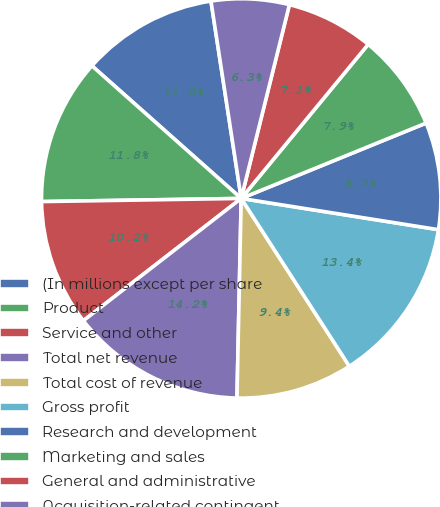Convert chart. <chart><loc_0><loc_0><loc_500><loc_500><pie_chart><fcel>(In millions except per share<fcel>Product<fcel>Service and other<fcel>Total net revenue<fcel>Total cost of revenue<fcel>Gross profit<fcel>Research and development<fcel>Marketing and sales<fcel>General and administrative<fcel>Acquisition-related contingent<nl><fcel>11.02%<fcel>11.81%<fcel>10.24%<fcel>14.17%<fcel>9.45%<fcel>13.39%<fcel>8.66%<fcel>7.87%<fcel>7.09%<fcel>6.3%<nl></chart> 